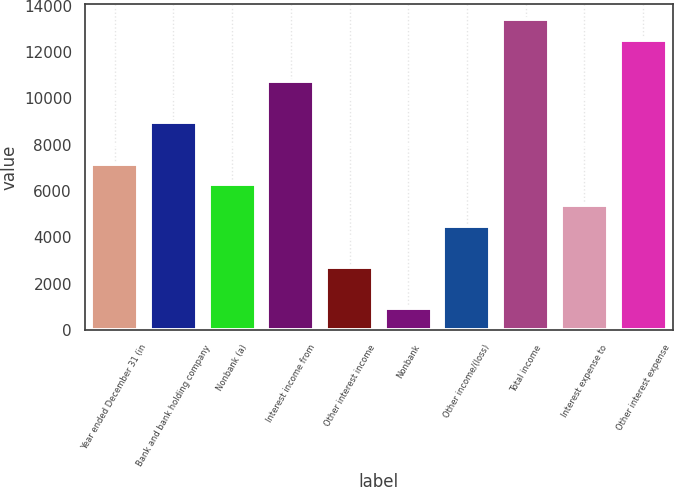Convert chart to OTSL. <chart><loc_0><loc_0><loc_500><loc_500><bar_chart><fcel>Year ended December 31 (in<fcel>Bank and bank holding company<fcel>Nonbank (a)<fcel>Interest income from<fcel>Other interest income<fcel>Nonbank<fcel>Other income/(loss)<fcel>Total income<fcel>Interest expense to<fcel>Other interest expense<nl><fcel>7173.4<fcel>8956<fcel>6282.1<fcel>10738.6<fcel>2716.9<fcel>934.3<fcel>4499.5<fcel>13412.5<fcel>5390.8<fcel>12521.2<nl></chart> 